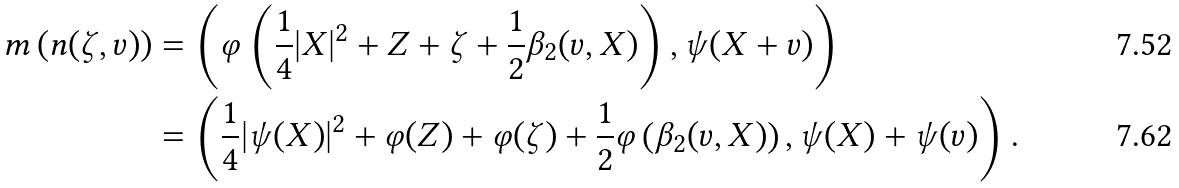Convert formula to latex. <formula><loc_0><loc_0><loc_500><loc_500>m \left ( n ( \zeta , v ) \right ) & = \left ( \varphi \left ( \frac { 1 } { 4 } | X | ^ { 2 } + Z + \zeta + \frac { 1 } { 2 } \beta _ { 2 } ( v , X ) \right ) , \psi ( X + v ) \right ) \\ & = \left ( \frac { 1 } { 4 } | \psi ( X ) | ^ { 2 } + \varphi ( Z ) + \varphi ( \zeta ) + \frac { 1 } { 2 } \varphi \left ( \beta _ { 2 } ( v , X ) \right ) , \psi ( X ) + \psi ( v ) \right ) .</formula> 